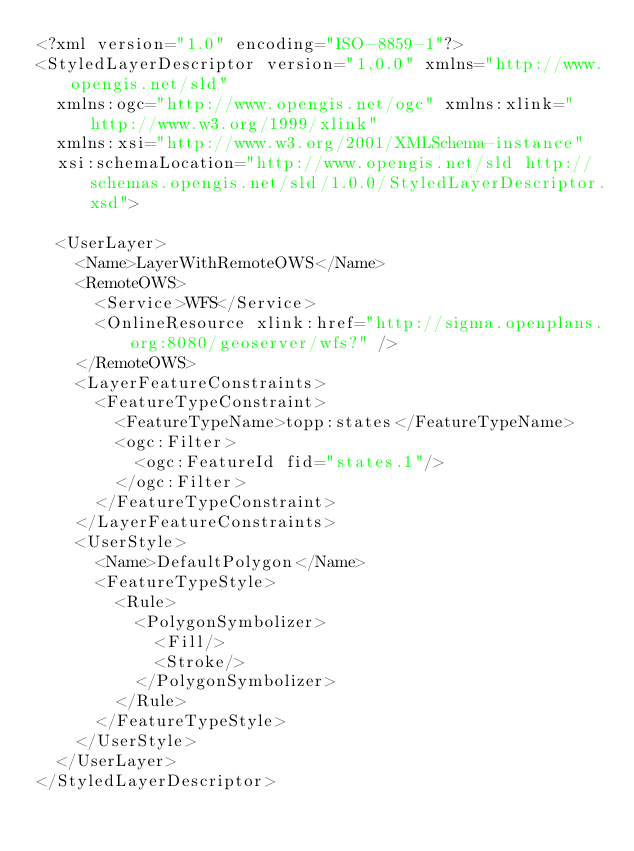Convert code to text. <code><loc_0><loc_0><loc_500><loc_500><_Scheme_><?xml version="1.0" encoding="ISO-8859-1"?>
<StyledLayerDescriptor version="1.0.0" xmlns="http://www.opengis.net/sld"
  xmlns:ogc="http://www.opengis.net/ogc" xmlns:xlink="http://www.w3.org/1999/xlink"
  xmlns:xsi="http://www.w3.org/2001/XMLSchema-instance"
  xsi:schemaLocation="http://www.opengis.net/sld http://schemas.opengis.net/sld/1.0.0/StyledLayerDescriptor.xsd">

  <UserLayer>
    <Name>LayerWithRemoteOWS</Name>
    <RemoteOWS>
      <Service>WFS</Service>
      <OnlineResource xlink:href="http://sigma.openplans.org:8080/geoserver/wfs?" />
    </RemoteOWS>
    <LayerFeatureConstraints>
      <FeatureTypeConstraint>
        <FeatureTypeName>topp:states</FeatureTypeName>
        <ogc:Filter>
          <ogc:FeatureId fid="states.1"/>
        </ogc:Filter>
      </FeatureTypeConstraint>
    </LayerFeatureConstraints>
    <UserStyle>
      <Name>DefaultPolygon</Name>
      <FeatureTypeStyle>
        <Rule>
          <PolygonSymbolizer>
            <Fill/>
            <Stroke/>
          </PolygonSymbolizer>
        </Rule>
      </FeatureTypeStyle>
    </UserStyle>
  </UserLayer>
</StyledLayerDescriptor>
</code> 